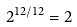Convert formula to latex. <formula><loc_0><loc_0><loc_500><loc_500>2 ^ { 1 2 / 1 2 } = 2</formula> 